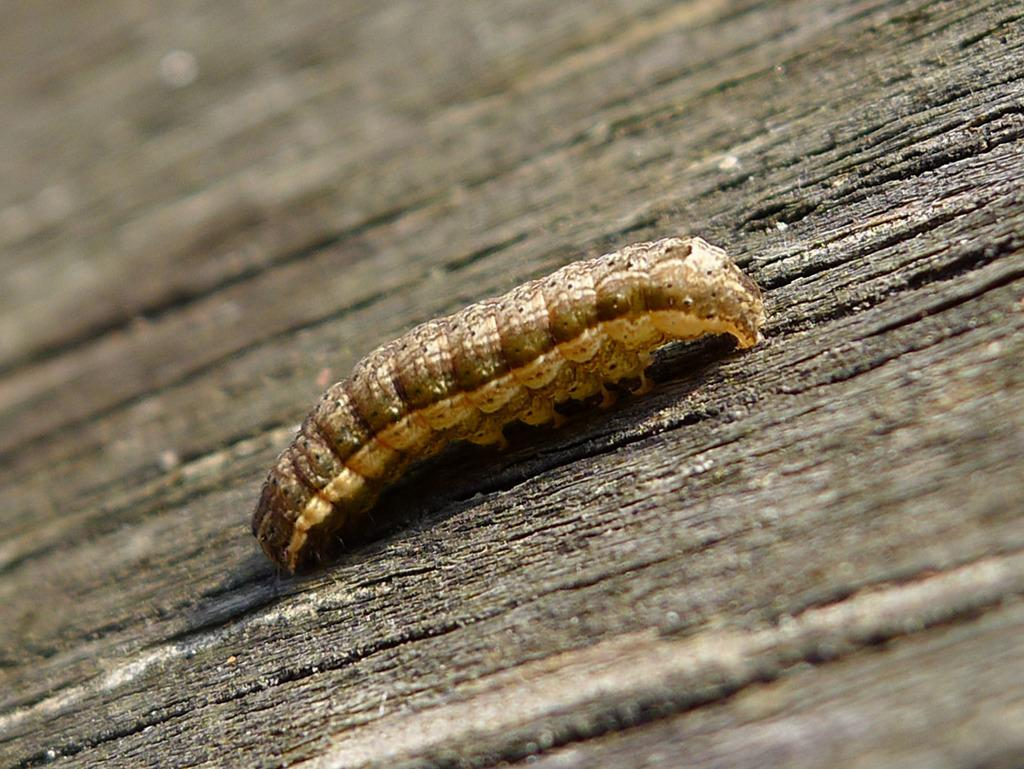What is the main subject of the image? The main subject of the image is a caterpillar. Where is the caterpillar located in the image? The caterpillar is in the center of the image. What type of surface is the caterpillar on? The caterpillar is on a wooden surface. How many mountains can be seen in the image? There are no mountains visible in the image; it features a caterpillar on a wooden surface. What type of care is being provided to the caterpillar in the image? There is no indication in the image that the caterpillar is receiving any care. 